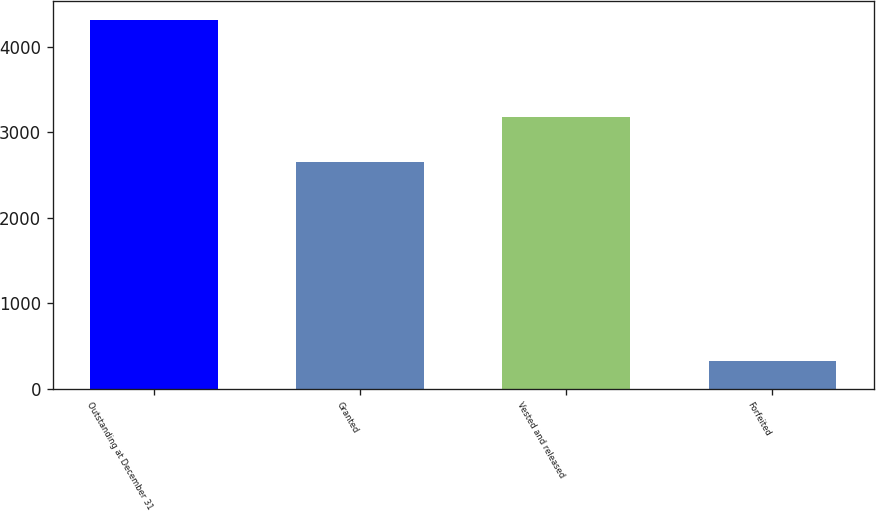Convert chart to OTSL. <chart><loc_0><loc_0><loc_500><loc_500><bar_chart><fcel>Outstanding at December 31<fcel>Granted<fcel>Vested and released<fcel>Forfeited<nl><fcel>4320<fcel>2655<fcel>3183.6<fcel>321<nl></chart> 